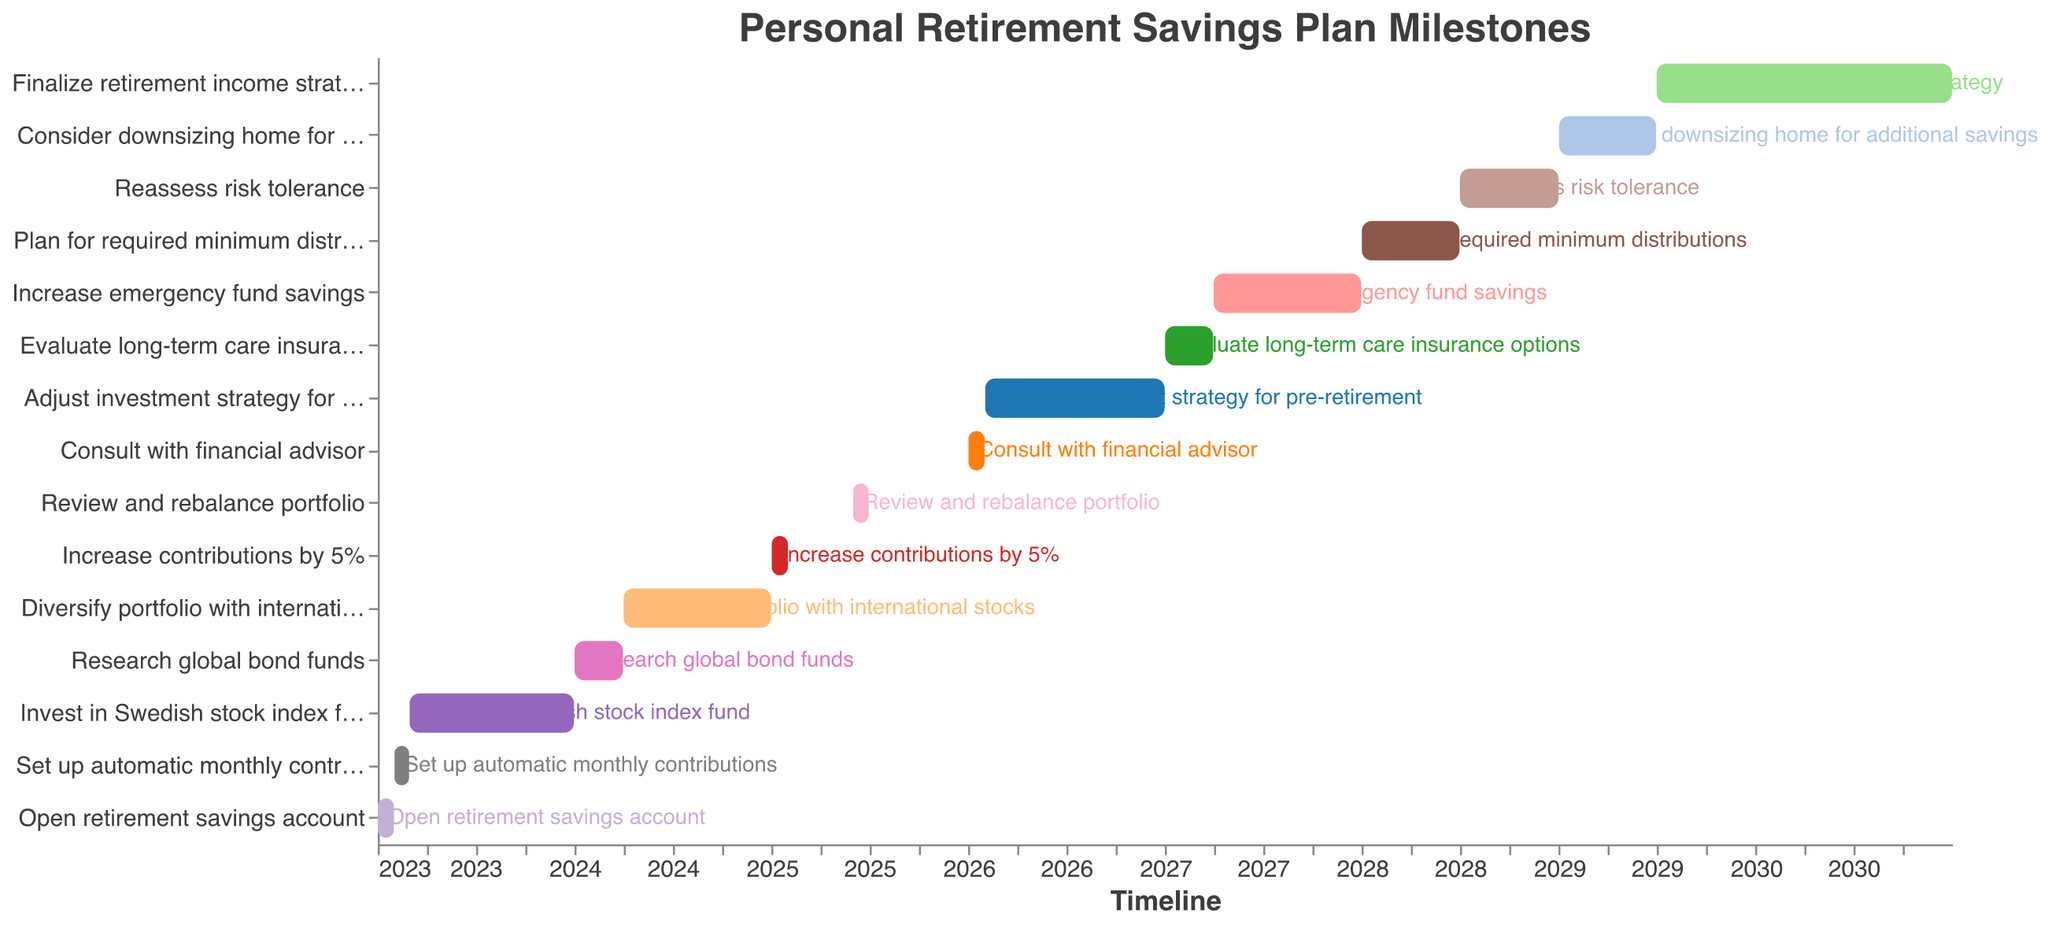What is the title of the Gantt Chart? The title is typically at the top of the chart, above the main visual area. In this case, the title indicates a broader understanding of what the chart represents. The title is "Personal Retirement Savings Plan Milestones."
Answer: Personal Retirement Savings Plan Milestones When do the first and last tasks start? To find the first and last tasks' start dates, look at the tasks that are closest to the beginning and end of the timeline on the x-axis. "Open retirement savings account" starts on 2023-01-01, and "Finalize retirement income strategy" starts on 2029-07-01.
Answer: 2023-01-01 and 2029-07-01 Which task has the longest duration? To determine the task with the longest duration, compare the length of the bars representing each task. The longest bar visually extends the furthest along the timeline. The task "Finalize retirement income strategy" spans from 2029-07-01 to 2030-12-31, which is the longest duration.
Answer: Finalize retirement income strategy How many tasks are planned for the year 2025? Look at the timeline axis and identify the tasks that begin and end within the year 2025. The tasks are "Increase contributions by 5%" in January, and "Review and rebalance portfolio" in June.
Answer: 2 Which tasks overlap in 2028? To identify overlapping tasks in 2028, look for bars that share time within that year. "Plan for required minimum distributions" (Jan to Jun) overlaps with "Reassess risk tolerance" (Jul to Dec).
Answer: Plan for required minimum distributions and Reassess risk tolerance In which month of 2024 does the diversification of the portfolio with international stocks begin? Look at the task labeled "Diversify portfolio with international stocks" to find its starting point on the x-axis. The task begins on 2024-04-01, which is April.
Answer: April Compare the duration of "Research global bond funds" with "Consult with financial advisor." Which one is longer? To compare the durations, measure the span of bars corresponding to these tasks. "Research global bond funds" runs from 2024-01-01 to 2024-03-31 (3 months), while "Consult with financial advisor" runs from 2026-01-01 to 2026-01-31 (1 month).
Answer: Research global bond funds What tasks are undertaken in February of 2026? Check the tasks marked for 2026 and identify which ones span across February. "Adjust investment strategy for pre-retirement" starts on 2026-02-01.
Answer: Adjust investment strategy for pre-retirement How many tasks span longer than 6 months? Count the tasks where the bars visually span more than half a year on the timeline. "Invest in Swedish stock index fund," "Diversify portfolio with international stocks," "Adjust investment strategy for pre-retirement," and "Finalize retirement income strategy" all span longer than 6 months.
Answer: 4 What's the time gap between setting up automatic monthly contributions and investing in the Swedish stock index fund? To determine the time gap, find the end date of "Set up automatic monthly contributions" (2023-02-28) and the start date of "Invest in Swedish stock index fund" (2023-03-01). The time gap is (2023-03-01) minus (2023-02-28), which is 1 day.
Answer: 1 day 